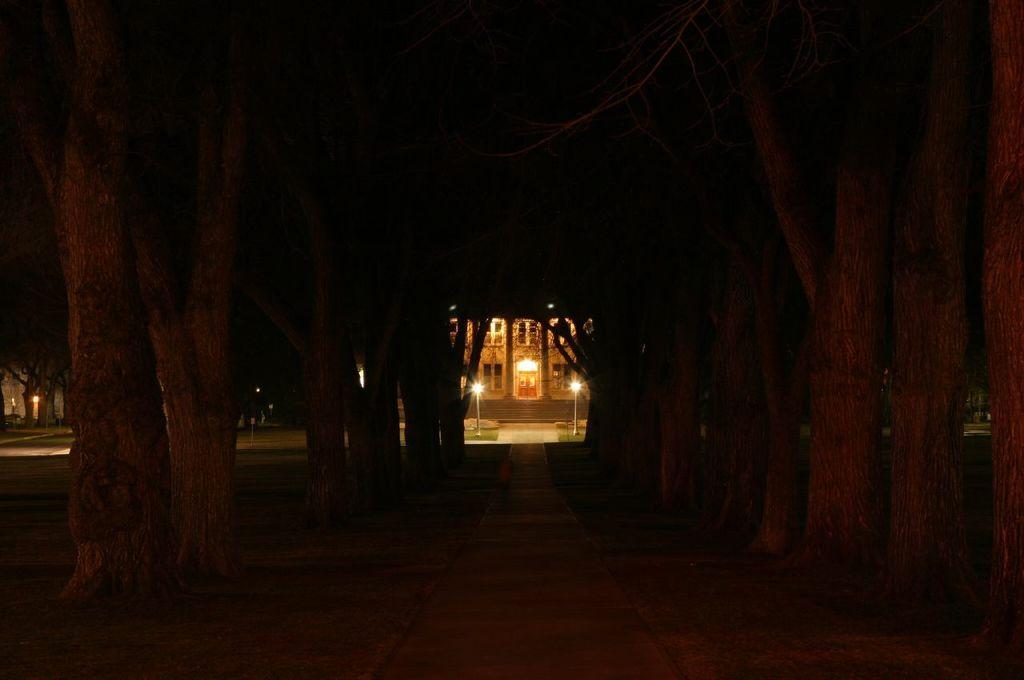How would you summarize this image in a sentence or two? In the picture we can see two rows of tree and in the middle of it we can see a path and in the background we can see a building with pillows and near the building we can see lights on the either sides and beside the building we can see trees. 